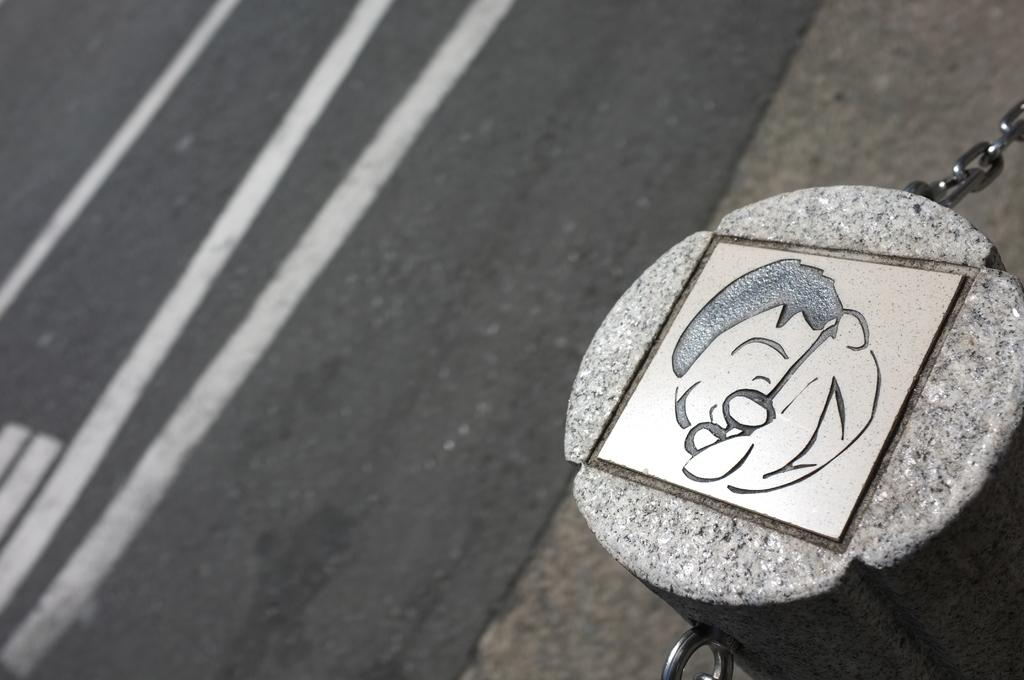What is the main subject of the picture? The main subject of the picture is a stone with an image. What else can be seen in the picture besides the stone? There are chains visible in the picture. What is the setting of the picture? The ground is visible in the picture. What letter is written on the stone in the picture? There is no letter written on the stone in the picture; it has an image instead. 